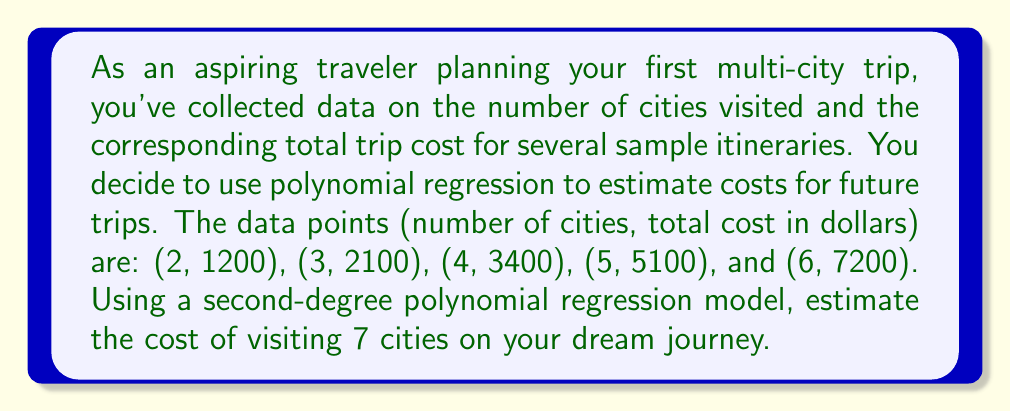Could you help me with this problem? Let's approach this step-by-step:

1) We're using a second-degree polynomial model, which has the form:
   $$ y = ax^2 + bx + c $$
   where $y$ is the total cost, and $x$ is the number of cities.

2) To find $a$, $b$, and $c$, we need to solve a system of normal equations. For a second-degree polynomial, these are:
   $$ \sum y = an\sum x^2 + b\sum x + nc $$
   $$ \sum xy = a\sum x^3 + b\sum x^2 + c\sum x $$
   $$ \sum x^2y = a\sum x^4 + b\sum x^3 + c\sum x^2 $$

3) Let's calculate the necessary sums:
   $\sum x = 2 + 3 + 4 + 5 + 6 = 20$
   $\sum y = 1200 + 2100 + 3400 + 5100 + 7200 = 19000$
   $\sum x^2 = 4 + 9 + 16 + 25 + 36 = 90$
   $\sum x^3 = 8 + 27 + 64 + 125 + 216 = 440$
   $\sum x^4 = 16 + 81 + 256 + 625 + 1296 = 2274$
   $\sum xy = 2400 + 6300 + 13600 + 25500 + 43200 = 91000$
   $\sum x^2y = 4800 + 18900 + 54400 + 127500 + 259200 = 464800$

4) Substituting these into our normal equations:
   $19000 = 90a + 20b + 5c$
   $91000 = 440a + 90b + 20c$
   $464800 = 2274a + 440b + 90c$

5) Solving this system of equations (using a calculator or computer algebra system) gives:
   $a = 180$
   $b = -70$
   $c = 490$

6) Therefore, our regression equation is:
   $$ y = 180x^2 - 70x + 490 $$

7) To estimate the cost for 7 cities, we substitute $x = 7$:
   $$ y = 180(7^2) - 70(7) + 490 = 180(49) - 490 + 490 = 8820 $$
Answer: The estimated cost of visiting 7 cities based on the polynomial regression model is $8,820. 